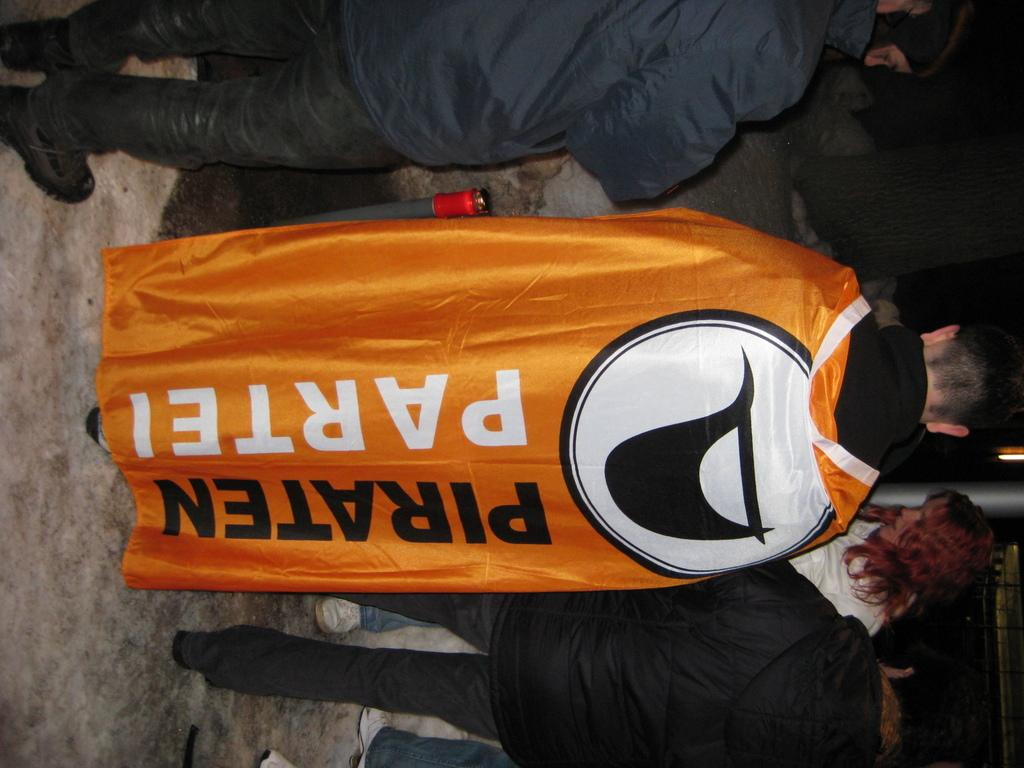<image>
Write a terse but informative summary of the picture. A cape has the words piraten partei on it. 